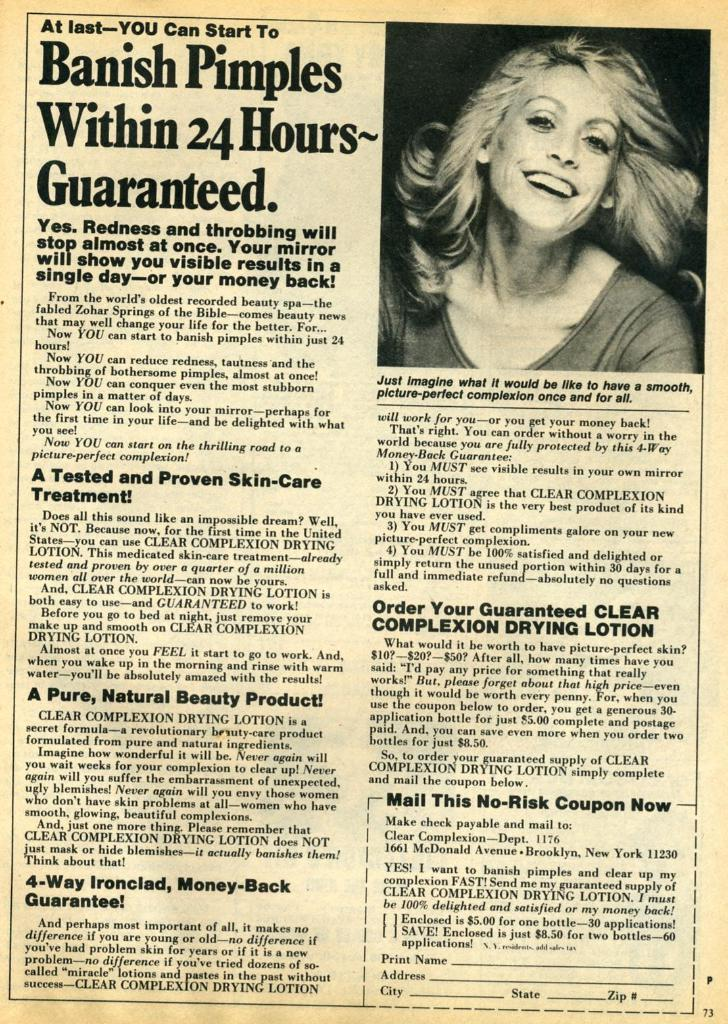What is the main object in the image? There is a pamphlet in the image. What can be found on the pamphlet? The pamphlet has text on it. Is there any image on the pamphlet? Yes, there is a picture of a lady on the pamphlet. What type of steel structure can be seen in the background of the image? There is no steel structure visible in the image; it only features a pamphlet with text and a picture of a lady. 